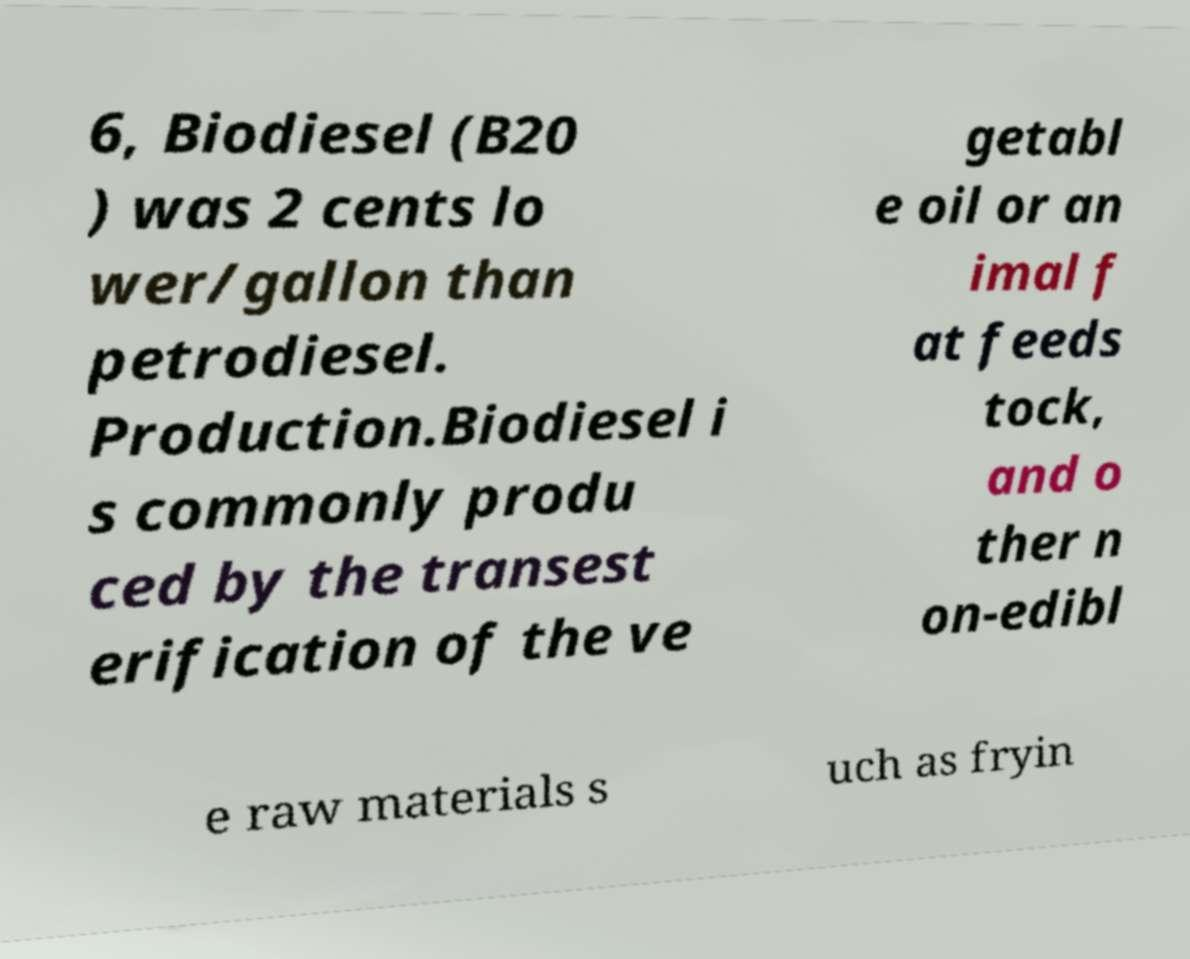Can you read and provide the text displayed in the image?This photo seems to have some interesting text. Can you extract and type it out for me? 6, Biodiesel (B20 ) was 2 cents lo wer/gallon than petrodiesel. Production.Biodiesel i s commonly produ ced by the transest erification of the ve getabl e oil or an imal f at feeds tock, and o ther n on-edibl e raw materials s uch as fryin 